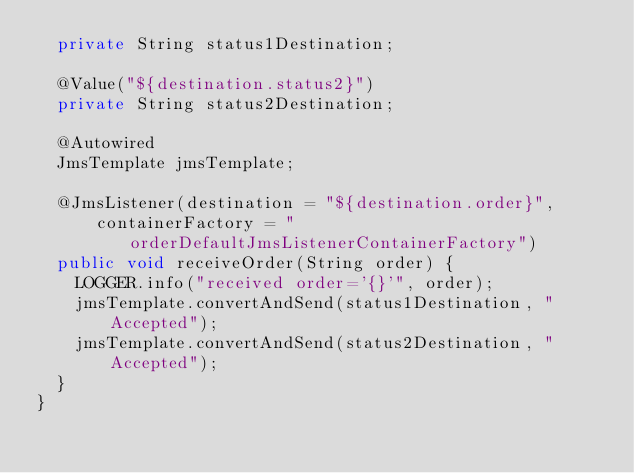<code> <loc_0><loc_0><loc_500><loc_500><_Java_>  private String status1Destination;

  @Value("${destination.status2}")
  private String status2Destination;

  @Autowired
  JmsTemplate jmsTemplate;

  @JmsListener(destination = "${destination.order}",
      containerFactory = "orderDefaultJmsListenerContainerFactory")
  public void receiveOrder(String order) {
    LOGGER.info("received order='{}'", order);
    jmsTemplate.convertAndSend(status1Destination, "Accepted");
    jmsTemplate.convertAndSend(status2Destination, "Accepted");
  }
}
</code> 